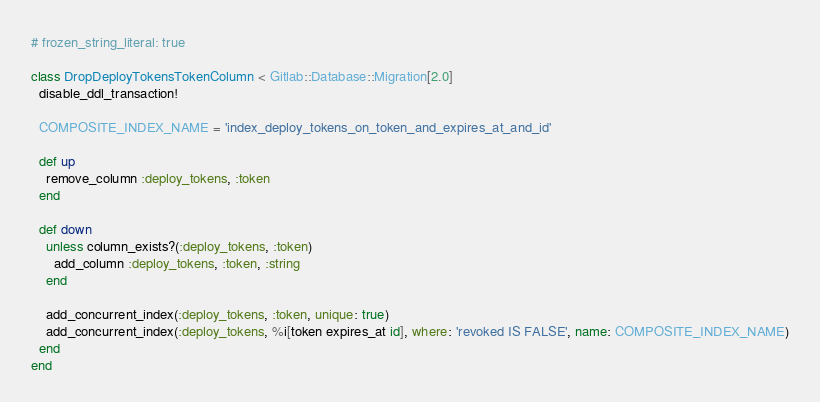Convert code to text. <code><loc_0><loc_0><loc_500><loc_500><_Ruby_># frozen_string_literal: true

class DropDeployTokensTokenColumn < Gitlab::Database::Migration[2.0]
  disable_ddl_transaction!

  COMPOSITE_INDEX_NAME = 'index_deploy_tokens_on_token_and_expires_at_and_id'

  def up
    remove_column :deploy_tokens, :token
  end

  def down
    unless column_exists?(:deploy_tokens, :token)
      add_column :deploy_tokens, :token, :string
    end

    add_concurrent_index(:deploy_tokens, :token, unique: true)
    add_concurrent_index(:deploy_tokens, %i[token expires_at id], where: 'revoked IS FALSE', name: COMPOSITE_INDEX_NAME)
  end
end
</code> 